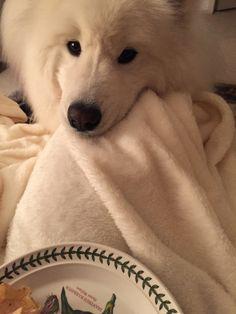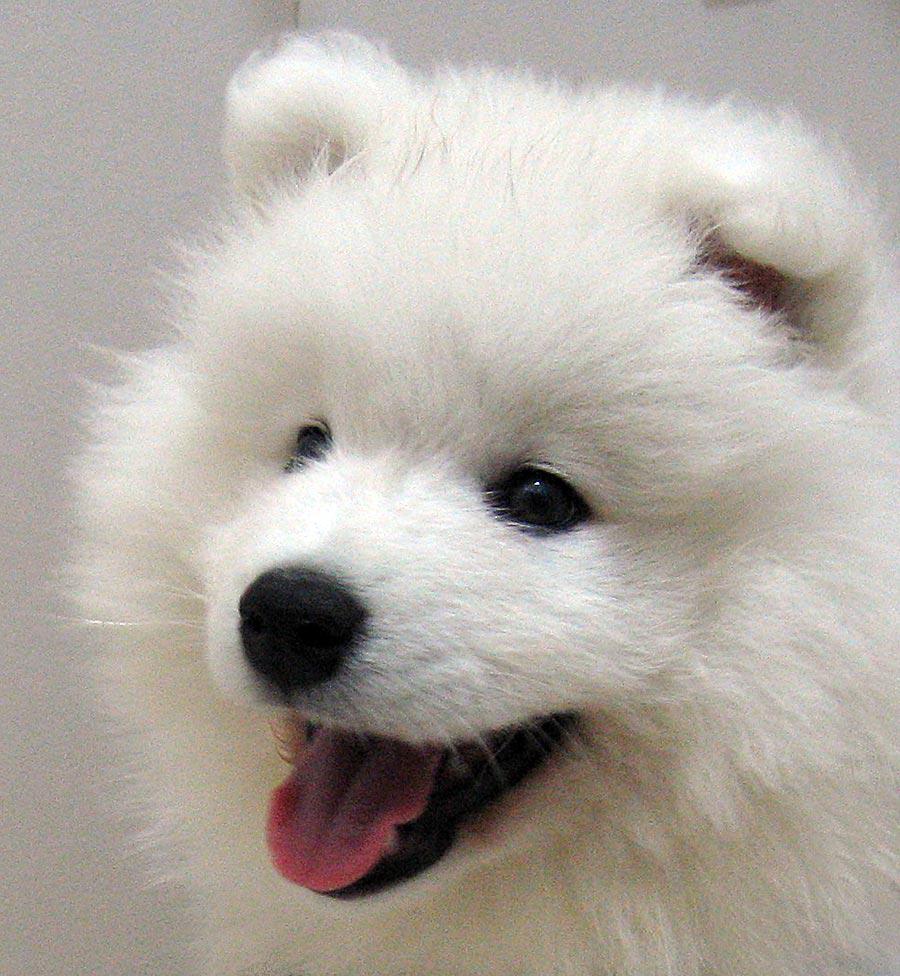The first image is the image on the left, the second image is the image on the right. Considering the images on both sides, is "An image includes more than one white dog in a prone position." valid? Answer yes or no. No. The first image is the image on the left, the second image is the image on the right. For the images shown, is this caption "There are less than four dogs and none of them have their mouth open." true? Answer yes or no. No. 